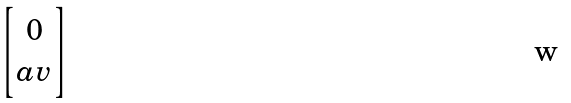<formula> <loc_0><loc_0><loc_500><loc_500>\begin{bmatrix} 0 \\ a v \end{bmatrix}</formula> 